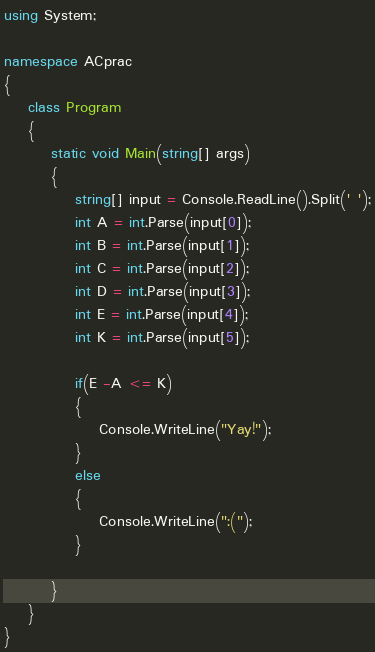<code> <loc_0><loc_0><loc_500><loc_500><_C#_>using System;

namespace ACprac
{
    class Program
    {
        static void Main(string[] args)
        {
            string[] input = Console.ReadLine().Split(' ');
            int A = int.Parse(input[0]);
            int B = int.Parse(input[1]);
            int C = int.Parse(input[2]);
            int D = int.Parse(input[3]);
            int E = int.Parse(input[4]);
            int K = int.Parse(input[5]);
           
            if(E -A <= K)
            {
                Console.WriteLine("Yay!");
            }
            else 
            {
                Console.WriteLine(":(");
            }
            
        }
    }
}</code> 